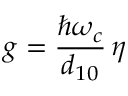<formula> <loc_0><loc_0><loc_500><loc_500>g = \frac { \hbar { \omega } _ { c } } { d _ { 1 0 } } \, \eta</formula> 